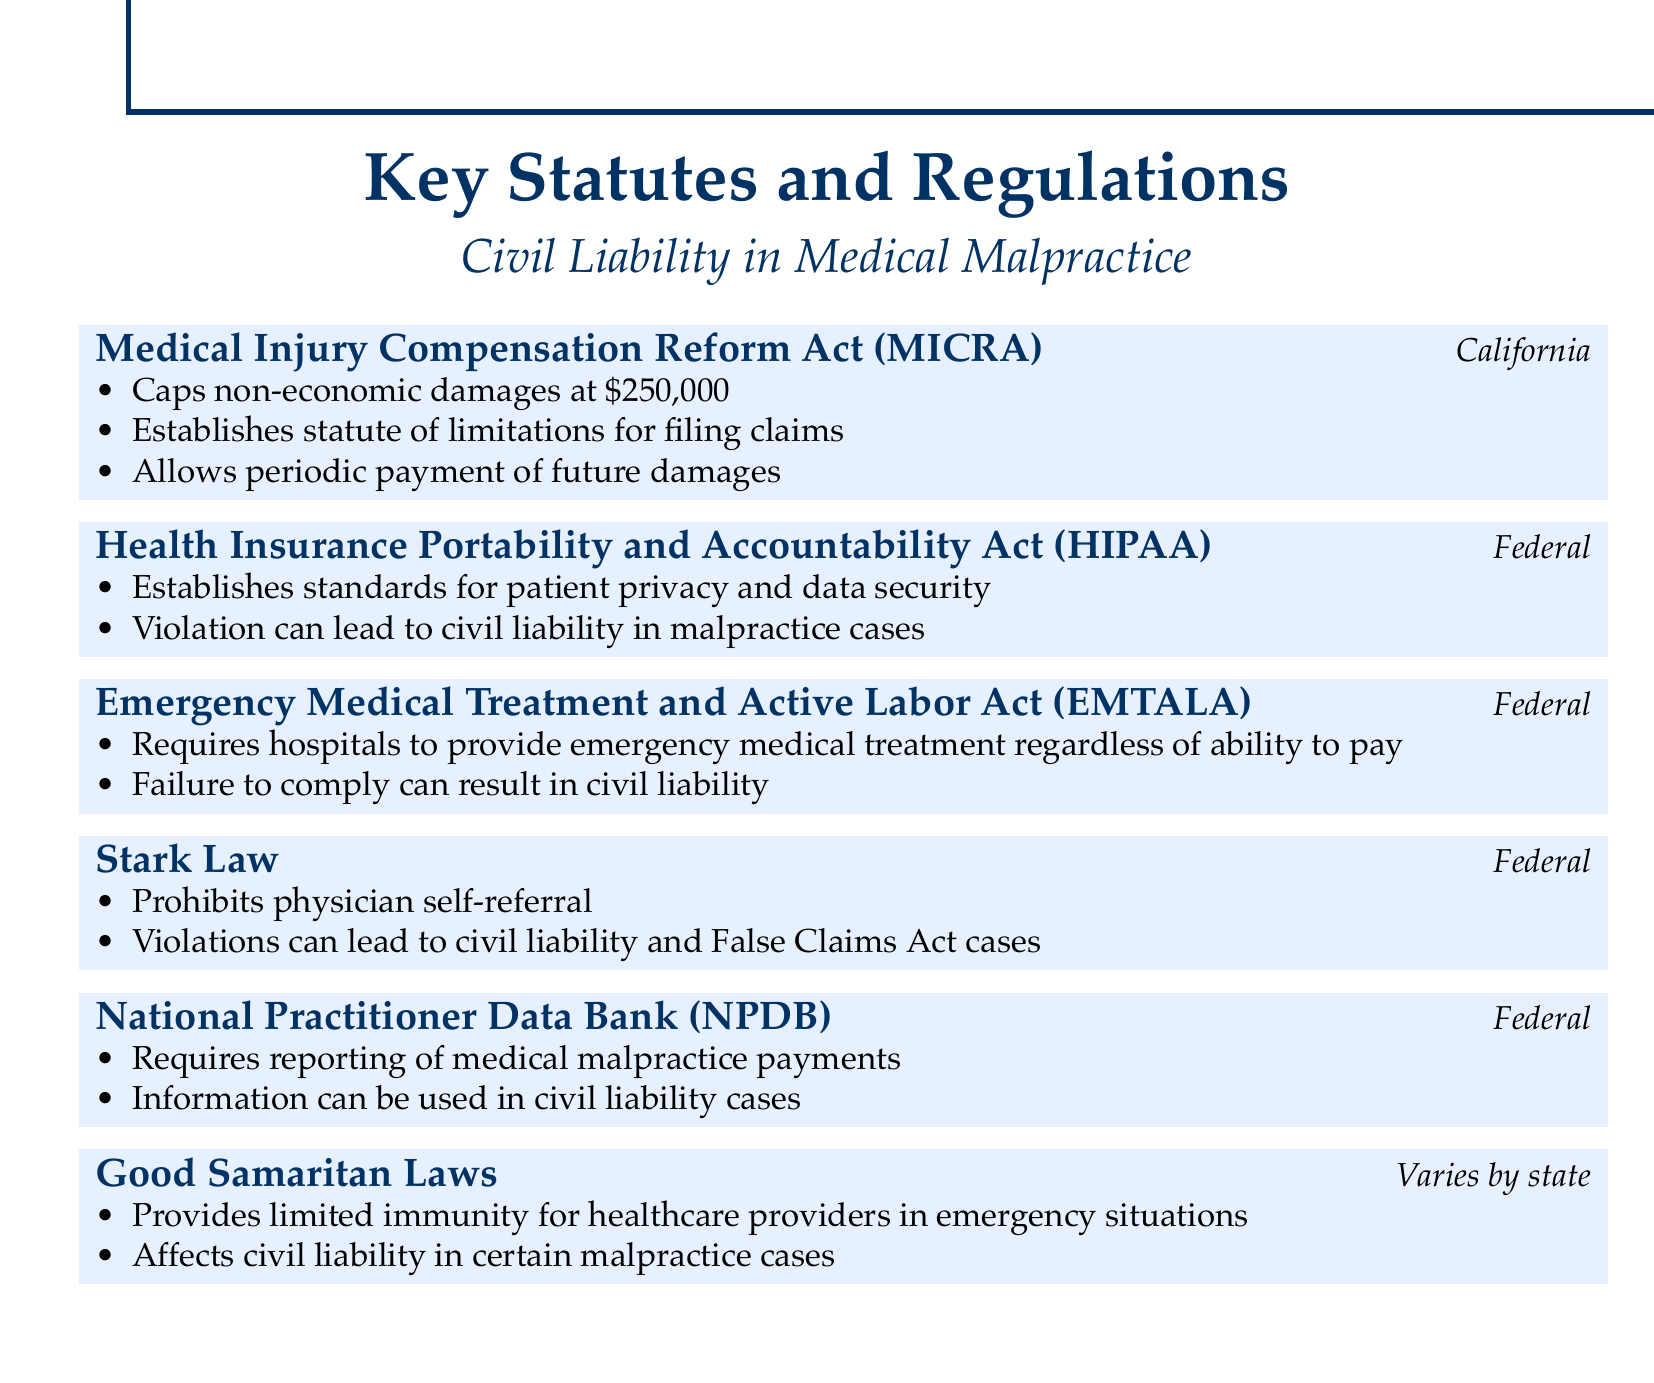What is the cap on non-economic damages under MICRA? The cap on non-economic damages under MICRA is stated in the document.
Answer: $250,000 What federal law establishes patient privacy standards? The document lists the Health Insurance Portability and Accountability Act as establishing patient privacy standards.
Answer: HIPAA What does EMTALA require hospitals to do? The document describes that EMTALA requires hospitals to provide emergency medical treatment.
Answer: Provide emergency medical treatment Which statute prohibits physician self-referral? The document indicates that the Stark Law prohibits physician self-referral.
Answer: Stark Law What is required to be reported to the NPDB? The document specifies that medical malpractice payments are required to be reported to the NPDB.
Answer: Medical malpractice payments What do Good Samaritan Laws provide to healthcare providers? The document states that Good Samaritan Laws provide limited immunity for healthcare providers.
Answer: Limited immunity Under which jurisdiction does MICRA apply? The document specifies that MICRA applies under California jurisdiction.
Answer: California What can happen if HIPAA is violated in malpractice cases? The document mentions that violation of HIPAA can lead to civil liability in malpractice cases.
Answer: Civil liability 